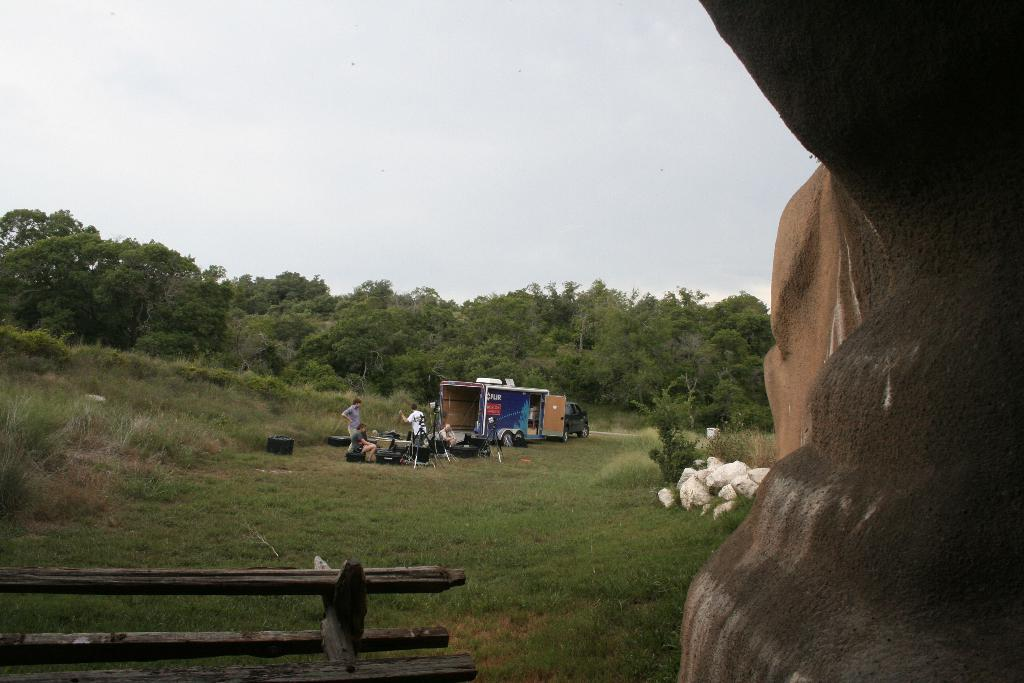What is the main feature of the image? There is a huge rock in the image. What type of vegetation is present around the rock? There is a lot of grass around the rock. Are there any other natural elements in the image? Yes, there are trees in the image. What else can be seen on the grass? There is a vehicle on the grass. Are there any people in the image? Yes, there are people in the image. What other objects are present in the image? There are other objects present in the image. What type of sheet is draped over the rock in the image? There is no sheet present in the image; it features a huge rock, grass, trees, a vehicle, people, and other objects. 